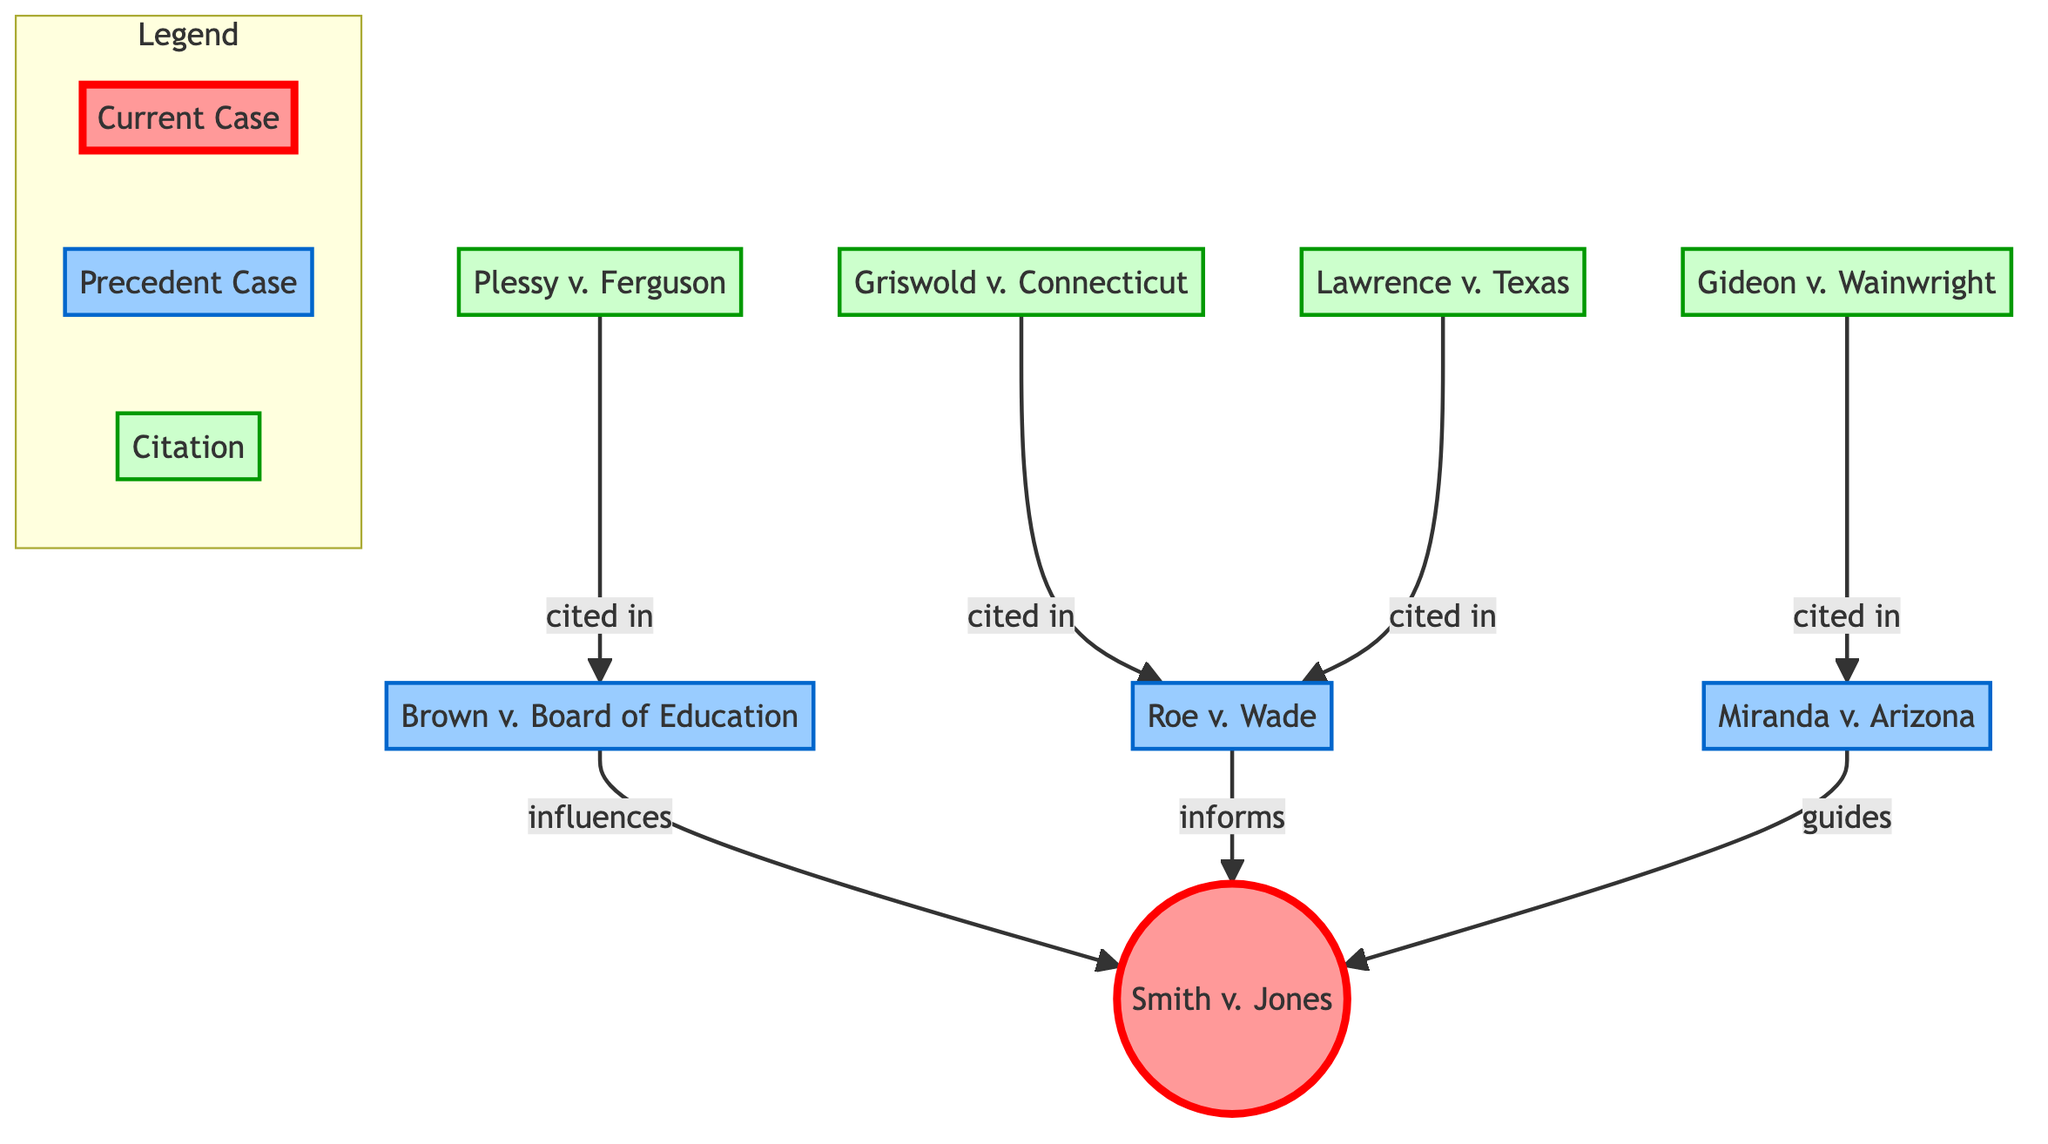What is the current case represented in the diagram? The diagram identifies the current case as "Smith v. Jones", which is highlighted prominently within the node labeled "Current Case".
Answer: Smith v. Jones How many precedent cases are there in the diagram? Reviewing the diagram, there are three nodes representing precedent cases: "Brown v. Board of Education", "Roe v. Wade", and "Miranda v. Arizona".
Answer: 3 Which case influences the current case? The edge leading from "Brown v. Board of Education" to "Smith v. Jones" is labeled as "influences", indicating that this precedent case influences the current case.
Answer: Brown v. Board of Education How many citations are represented in the diagram? There are a total of four citation nodes: "Griswold v. Connecticut", "Gideon v. Wainwright", "Lawrence v. Texas", and "Plessy v. Ferguson", as observed in the lower part of the diagram.
Answer: 4 Which precedent case is informed by the case "Griswold v. Connecticut"? "Griswold v. Connecticut" has a directed edge leading to "Roe v. Wade" labeled as "cited in", indicating that it informs or references this precedent case.
Answer: Roe v. Wade Which case guides the current case? The connection from "Miranda v. Arizona" to "Smith v. Jones", labeled "guides", indicates that this precedent case guides the current case.
Answer: Miranda v. Arizona What relationship does "Gideon v. Wainwright" have with "Miranda v. Arizona"? There is a directed edge from "Gideon v. Wainwright" to "Miranda v. Arizona", indicating that the former is cited in the latter, establishing a relationship of citation.
Answer: cited in Which two precedent cases are cited in "Roe v. Wade"? There are two citations directed towards "Roe v. Wade": one from "Griswold v. Connecticut" and another from "Lawrence v. Texas", indicating both cases are cited in this precedent case.
Answer: Griswold v. Connecticut, Lawrence v. Texas What color represents the current case in the diagram? The color filling the node for the current case, "Smith v. Jones", is a light red indicated by the fill color in the diagram styling.
Answer: light red 